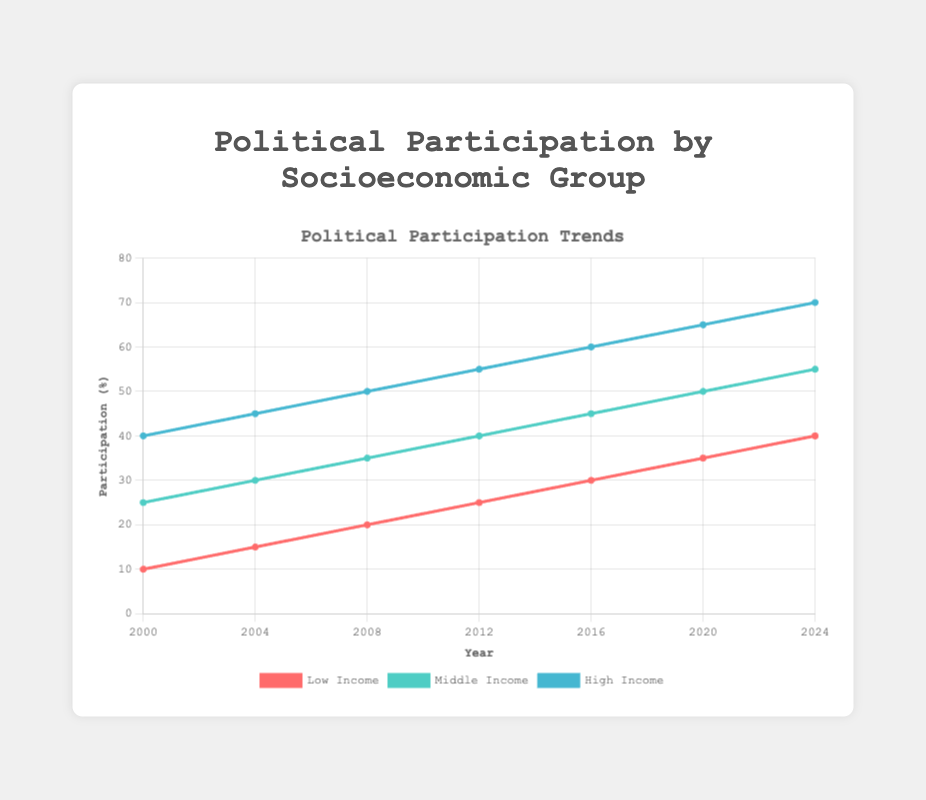What's the overall trend in political participation among the three income groups from 2000 to 2024? For all three socioeconomic groups, the trend shows a consistent increase in political participation over the years. By visually following each line (red for Low Income, green for Middle Income, blue for High Income), it's evident that the values rise steadily from left (2000) to right (2024).
Answer: Rising trend In 2016, which group had the highest political participation? By observing the value points for the year 2016 on each line, the High Income group, represented by the blue line, has the highest point compared to red (Low Income) and green (Middle Income).
Answer: High Income What is the difference in political participation between Low Income and High Income groups in 2020? The value of political participation in 2020 for Low Income is 35 and for High Income is 65. Subtracting these two values gives 65 - 35.
Answer: 30 Which socioeconomic group shows the fastest growth in political participation from 2000 to 2024? To determine the fastest growth, compare the initial and final values for each group: Low Income (40 - 10 = 30), Middle Income (55 - 25 = 30), High Income (70 - 40 = 30). Since all groups show the same increase in numerical value, no group has a faster growth relative to others.
Answer: No group (equal growth) What was the average political participation of the Middle Income group between 2008 and 2016? The values for Middle Income for the years 2008, 2012, and 2016 are 35, 40, and 45. Sum these values and then divide by the number of years (3): (35 + 40 + 45)/3.
Answer: 40 How does the political participation of Middle and High Income groups compare in 2012? Observing the 2012 values, Middle Income participation is 40 and High Income participation is 55. Since 40 is less than 55, the Middle Income group has lower participation.
Answer: Middle Income is lower By how much did political participation in the Low Income group increase from 2000 to 2008? The political participation value for Low Income in 2000 is 10 and in 2008 it is 20. The increase is calculated as 20 - 10.
Answer: 10 What color represents the Middle Income group's political participation on the chart? Observing the line chart, the Middle Income group is represented by the green-colored line.
Answer: Green Calculate the compound annual growth rate (CAGR) of political participation for the High Income group from 2000 to 2024. The formula for CAGR is [(Ending Value/Beginning Value)^(1/Number of Years)] - 1. Here, the Beginning Value is 40 (in 2000) and the Ending Value is 70 (in 2024), over 24 years: 
[(70/40)^(1/24)] - 1. This requires more detailed calculation steps:
1. 70/40 = 1.75
2. (1.75)^(1/24) ≈ 1.02327
3. 1.02327 - 1 ≈ 0.02327 or 2.327%
Answer: 2.327% Between 2000 and 2004, which group showed the highest rate of increase in political participation? Rate of increase is calculated as (New value - Initial value)/Initial value. Low Income: (15-10)/10 = 0.5 or 50%, Middle Income: (30-25)/25 = 0.2 or 20%, High Income: (45-40)/40 = 0.125 or 12.5%. The Low Income group has the highest rate of increase.
Answer: Low Income 